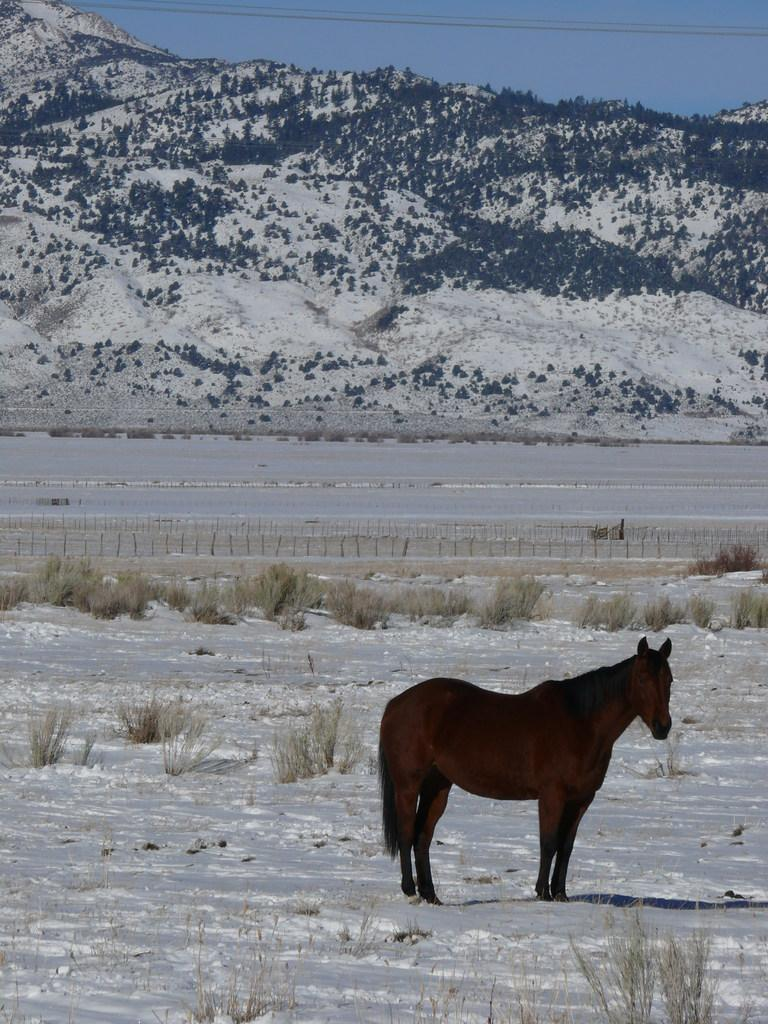What type of animal is in the image? There is a brown color horse in the image. Where is the horse located? The horse is on a snow surface of a ground. What is the ground covered with? The ground has grass on it. What can be seen in the background of the image? There are mountains and cables in the background of the image. What color is the sky in the image? The sky is blue in the image. What is the taste of the horse in the image? Horses do not have a taste, as they are animals and not food items. 